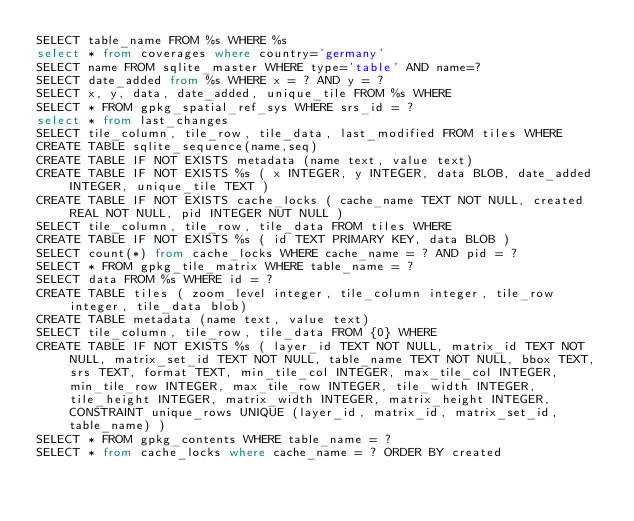Convert code to text. <code><loc_0><loc_0><loc_500><loc_500><_SQL_>SELECT table_name FROM %s WHERE %s
select * from coverages where country='germany'
SELECT name FROM sqlite_master WHERE type='table' AND name=?
SELECT date_added from %s WHERE x = ? AND y = ?
SELECT x, y, data, date_added, unique_tile FROM %s WHERE 
SELECT * FROM gpkg_spatial_ref_sys WHERE srs_id = ?
select * from last_changes
SELECT tile_column, tile_row, tile_data, last_modified FROM tiles WHERE 
CREATE TABLE sqlite_sequence(name,seq)
CREATE TABLE IF NOT EXISTS metadata (name text, value text)
CREATE TABLE IF NOT EXISTS %s ( x INTEGER, y INTEGER, data BLOB, date_added INTEGER, unique_tile TEXT )
CREATE TABLE IF NOT EXISTS cache_locks ( cache_name TEXT NOT NULL, created REAL NOT NULL, pid INTEGER NUT NULL )
SELECT tile_column, tile_row, tile_data FROM tiles WHERE 
CREATE TABLE IF NOT EXISTS %s ( id TEXT PRIMARY KEY, data BLOB )
SELECT count(*) from cache_locks WHERE cache_name = ? AND pid = ?
SELECT * FROM gpkg_tile_matrix WHERE table_name = ?
SELECT data FROM %s WHERE id = ?
CREATE TABLE tiles ( zoom_level integer, tile_column integer, tile_row integer, tile_data blob)
CREATE TABLE metadata (name text, value text)
SELECT tile_column, tile_row, tile_data FROM {0} WHERE 
CREATE TABLE IF NOT EXISTS %s ( layer_id TEXT NOT NULL, matrix_id TEXT NOT NULL, matrix_set_id TEXT NOT NULL, table_name TEXT NOT NULL, bbox TEXT, srs TEXT, format TEXT, min_tile_col INTEGER, max_tile_col INTEGER, min_tile_row INTEGER, max_tile_row INTEGER, tile_width INTEGER, tile_height INTEGER, matrix_width INTEGER, matrix_height INTEGER, CONSTRAINT unique_rows UNIQUE (layer_id, matrix_id, matrix_set_id, table_name) )
SELECT * FROM gpkg_contents WHERE table_name = ?
SELECT * from cache_locks where cache_name = ? ORDER BY created
</code> 